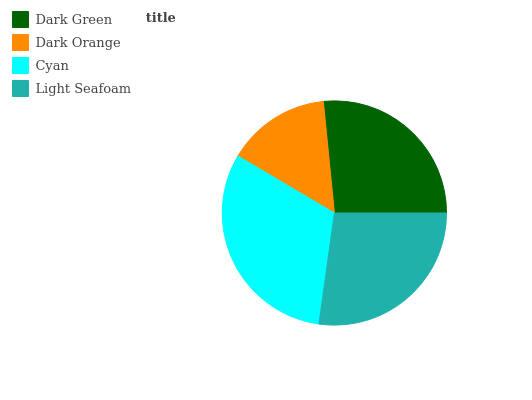Is Dark Orange the minimum?
Answer yes or no. Yes. Is Cyan the maximum?
Answer yes or no. Yes. Is Cyan the minimum?
Answer yes or no. No. Is Dark Orange the maximum?
Answer yes or no. No. Is Cyan greater than Dark Orange?
Answer yes or no. Yes. Is Dark Orange less than Cyan?
Answer yes or no. Yes. Is Dark Orange greater than Cyan?
Answer yes or no. No. Is Cyan less than Dark Orange?
Answer yes or no. No. Is Light Seafoam the high median?
Answer yes or no. Yes. Is Dark Green the low median?
Answer yes or no. Yes. Is Dark Orange the high median?
Answer yes or no. No. Is Light Seafoam the low median?
Answer yes or no. No. 